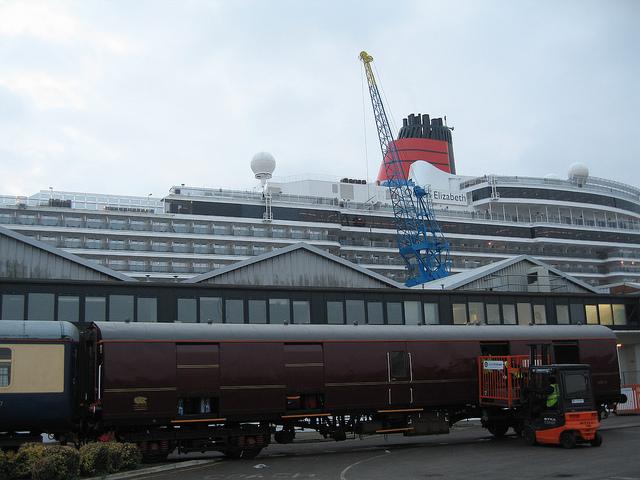Are there clouds?
Answer briefly. Yes. What color is the forklift?
Quick response, please. Blue. Which mode of transport weighs the most?
Write a very short answer. Ship. What color is the crane?
Keep it brief. Blue. 